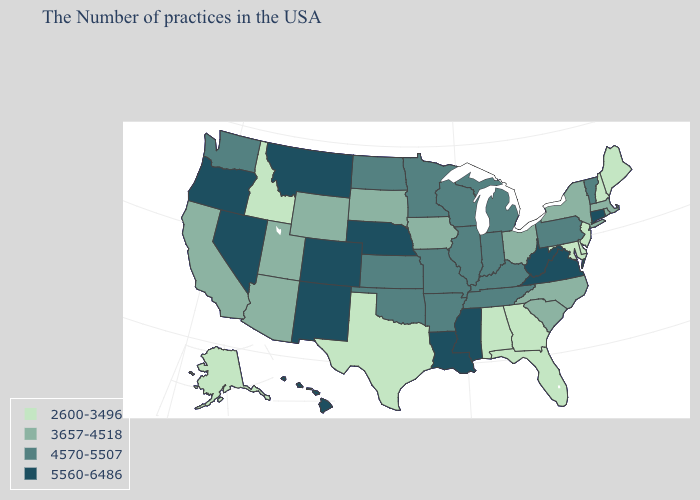What is the value of Virginia?
Write a very short answer. 5560-6486. Which states have the highest value in the USA?
Keep it brief. Connecticut, Virginia, West Virginia, Mississippi, Louisiana, Nebraska, Colorado, New Mexico, Montana, Nevada, Oregon, Hawaii. What is the value of Hawaii?
Concise answer only. 5560-6486. What is the lowest value in states that border Iowa?
Give a very brief answer. 3657-4518. Name the states that have a value in the range 2600-3496?
Keep it brief. Maine, New Hampshire, New Jersey, Delaware, Maryland, Florida, Georgia, Alabama, Texas, Idaho, Alaska. Which states have the lowest value in the South?
Keep it brief. Delaware, Maryland, Florida, Georgia, Alabama, Texas. Name the states that have a value in the range 4570-5507?
Short answer required. Vermont, Pennsylvania, Michigan, Kentucky, Indiana, Tennessee, Wisconsin, Illinois, Missouri, Arkansas, Minnesota, Kansas, Oklahoma, North Dakota, Washington. Which states hav the highest value in the South?
Give a very brief answer. Virginia, West Virginia, Mississippi, Louisiana. Name the states that have a value in the range 3657-4518?
Quick response, please. Massachusetts, Rhode Island, New York, North Carolina, South Carolina, Ohio, Iowa, South Dakota, Wyoming, Utah, Arizona, California. Does New Mexico have the highest value in the USA?
Short answer required. Yes. Does North Carolina have the lowest value in the South?
Be succinct. No. Which states have the lowest value in the USA?
Be succinct. Maine, New Hampshire, New Jersey, Delaware, Maryland, Florida, Georgia, Alabama, Texas, Idaho, Alaska. What is the value of South Carolina?
Answer briefly. 3657-4518. Does the first symbol in the legend represent the smallest category?
Answer briefly. Yes. Among the states that border Iowa , does Nebraska have the highest value?
Write a very short answer. Yes. 